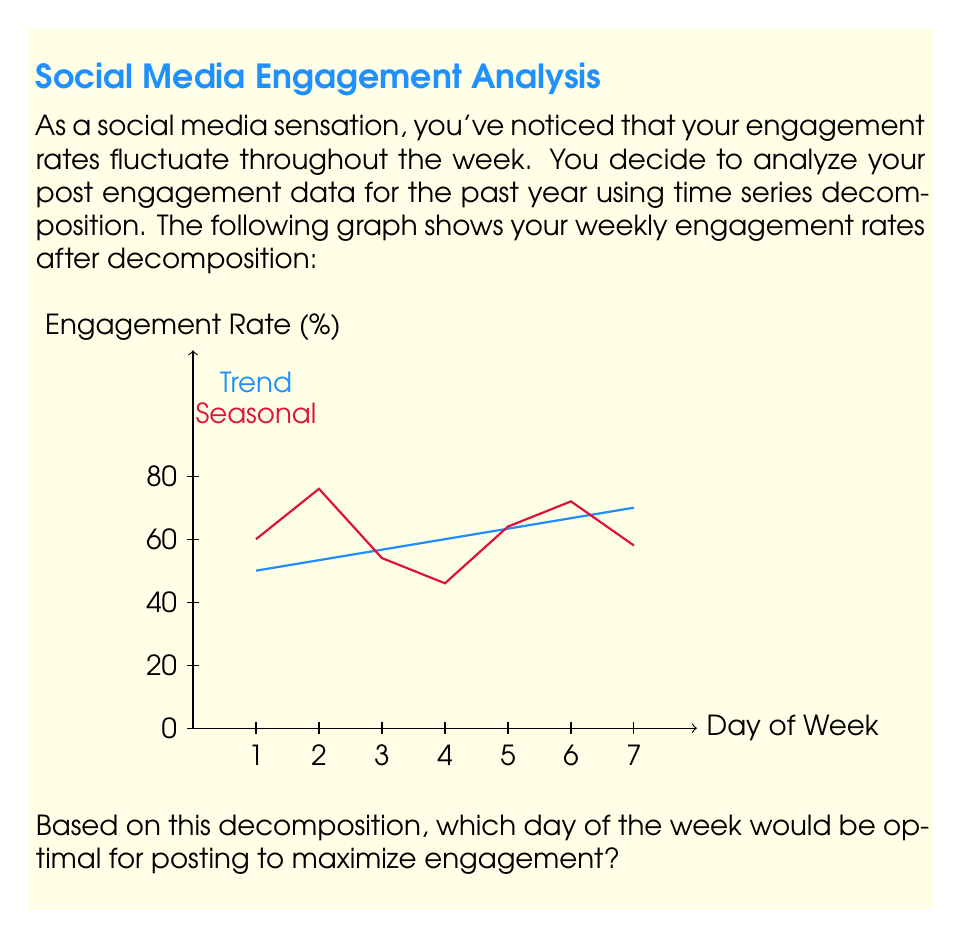Give your solution to this math problem. To determine the optimal posting day, we need to analyze the seasonal component of the time series decomposition, as it represents the recurring weekly pattern in engagement rates.

Step 1: Identify the seasonal pattern
The red line in the graph represents the seasonal component. We need to find the day with the highest positive deviation from the trend.

Step 2: Analyze each day
Day 1: Moderate positive deviation
Day 2: Highest positive deviation
Day 3: Slight negative deviation
Day 4: Largest negative deviation
Day 5: Small positive deviation
Day 6: Second-highest positive deviation
Day 7: Slight negative deviation

Step 3: Interpret the results
The seasonal component shows that Day 2 has the highest positive deviation from the trend. This indicates that, on average, engagement rates are highest on the second day of the week, regardless of the overall trend.

Step 4: Consider the trend
The blue line representing the trend is slightly increasing over the week. However, the difference in the trend between days is much smaller than the seasonal variations, so it doesn't significantly affect our decision.

Step 5: Conclusion
Based on the seasonal component of the time series decomposition, Day 2 consistently shows the highest engagement rates relative to the trend, making it the optimal day for posting to maximize engagement.
Answer: Day 2 